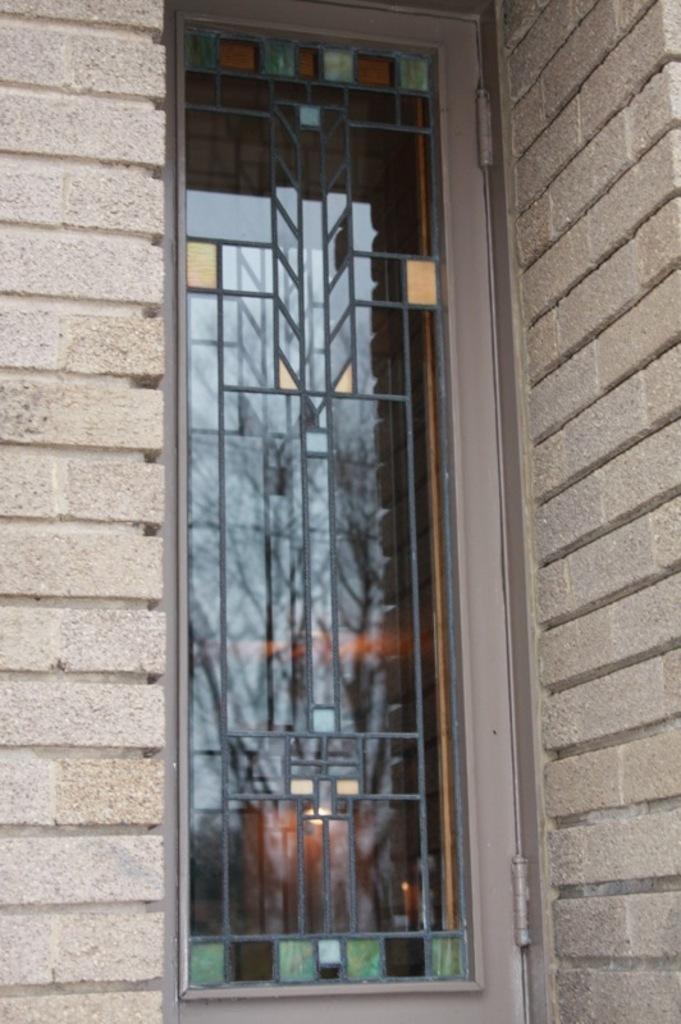Please provide a concise description of this image. In this image we can see a building with a window. 